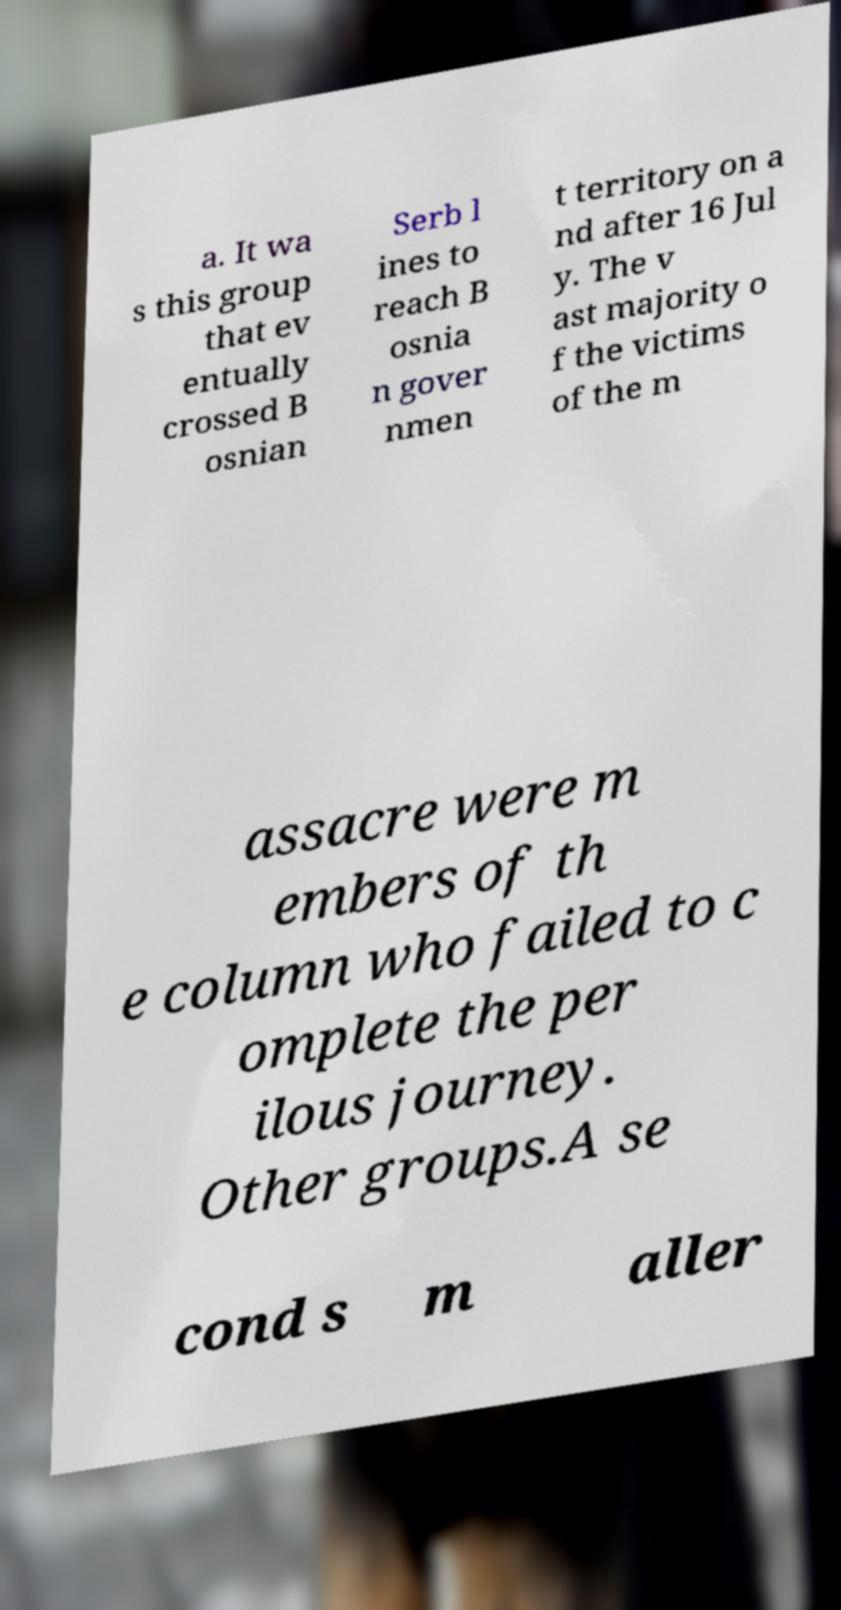Could you assist in decoding the text presented in this image and type it out clearly? a. It wa s this group that ev entually crossed B osnian Serb l ines to reach B osnia n gover nmen t territory on a nd after 16 Jul y. The v ast majority o f the victims of the m assacre were m embers of th e column who failed to c omplete the per ilous journey. Other groups.A se cond s m aller 